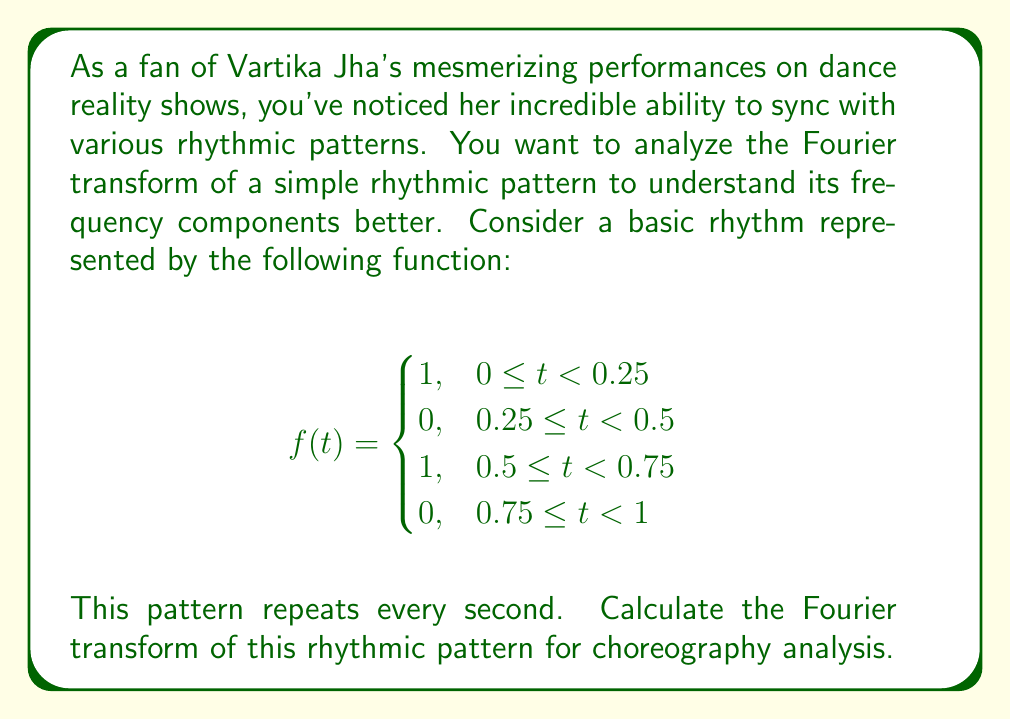What is the answer to this math problem? To calculate the Fourier transform of the given rhythmic pattern, we'll follow these steps:

1) The Fourier transform is given by:
   $$F(\omega) = \int_{-\infty}^{\infty} f(t) e^{-i\omega t} dt$$

2) Since our function is periodic with period T = 1, we can calculate the Fourier series coefficients instead:
   $$c_n = \frac{1}{T} \int_0^T f(t) e^{-i2\pi nt} dt$$

3) Substituting our function:
   $$c_n = \int_0^{0.25} e^{-i2\pi nt} dt + \int_{0.5}^{0.75} e^{-i2\pi nt} dt$$

4) Evaluating the integrals:
   $$c_n = \left[-\frac{1}{i2\pi n}e^{-i2\pi nt}\right]_0^{0.25} + \left[-\frac{1}{i2\pi n}e^{-i2\pi nt}\right]_{0.5}^{0.75}$$

5) Simplifying:
   $$c_n = \frac{1}{i2\pi n}(1 - e^{-i\pi n/2} + e^{-i\pi n} - e^{-3i\pi n/2})$$

6) Using Euler's formula, $e^{ix} = \cos x + i\sin x$:
   $$c_n = \frac{1}{2\pi n}(2 - 2\cos(\pi n/2))$$

7) For n even, $c_n = 0$. For n odd:
   $$c_n = \frac{2}{\pi n}$$

8) The Fourier transform F(ω) is related to these coefficients:
   $$F(\omega) = 2\pi \sum_{n=-\infty}^{\infty} c_n \delta(\omega - 2\pi n)$$

Where δ is the Dirac delta function.
Answer: $$F(\omega) = 2\pi \sum_{n \text{ odd}} \frac{2}{\pi n} \delta(\omega - 2\pi n)$$ 